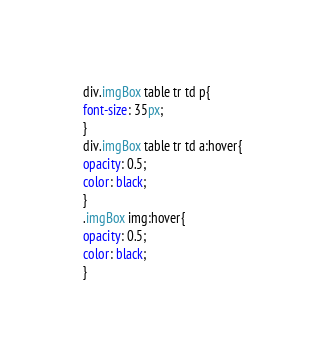<code> <loc_0><loc_0><loc_500><loc_500><_CSS_>div.imgBox table tr td p{
font-size: 35px;
}
div.imgBox table tr td a:hover{
opacity: 0.5;
color: black;
}
.imgBox img:hover{
opacity: 0.5;
color: black;
}
</code> 